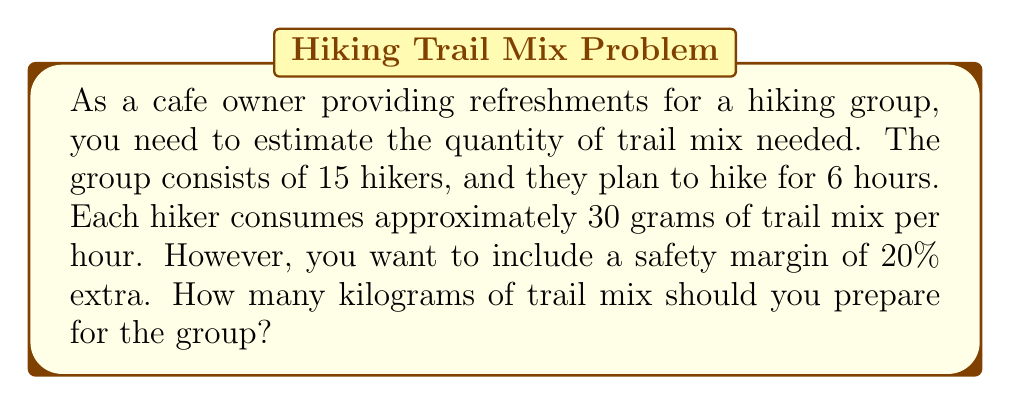Teach me how to tackle this problem. Let's break this problem down step by step:

1. Calculate the base amount of trail mix per hiker:
   $$ \text{Base amount per hiker} = 30 \text{ g/hour} \times 6 \text{ hours} = 180 \text{ g} $$

2. Calculate the total base amount for all hikers:
   $$ \text{Total base amount} = 180 \text{ g} \times 15 \text{ hikers} = 2700 \text{ g} $$

3. Add the 20% safety margin:
   $$ \text{Safety margin} = 2700 \text{ g} \times 0.20 = 540 \text{ g} $$

4. Calculate the total amount including the safety margin:
   $$ \text{Total amount} = 2700 \text{ g} + 540 \text{ g} = 3240 \text{ g} $$

5. Convert grams to kilograms:
   $$ \text{Amount in kg} = 3240 \text{ g} \div 1000 \text{ g/kg} = 3.24 \text{ kg} $$

Therefore, you should prepare 3.24 kg of trail mix for the hiking group.
Answer: 3.24 kg 